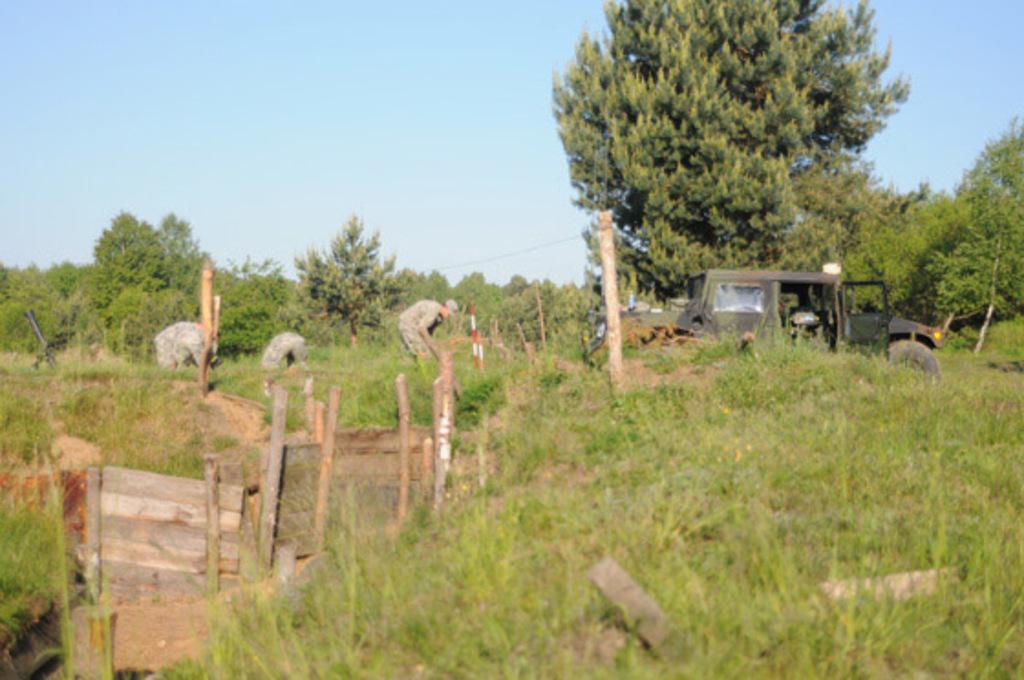Could you give a brief overview of what you see in this image? In this image in the center there are some persons and a vehicle, at the bottom there is grass and some wooden boards and poles. In the background there are some trees, at the top of the image there is sky. 